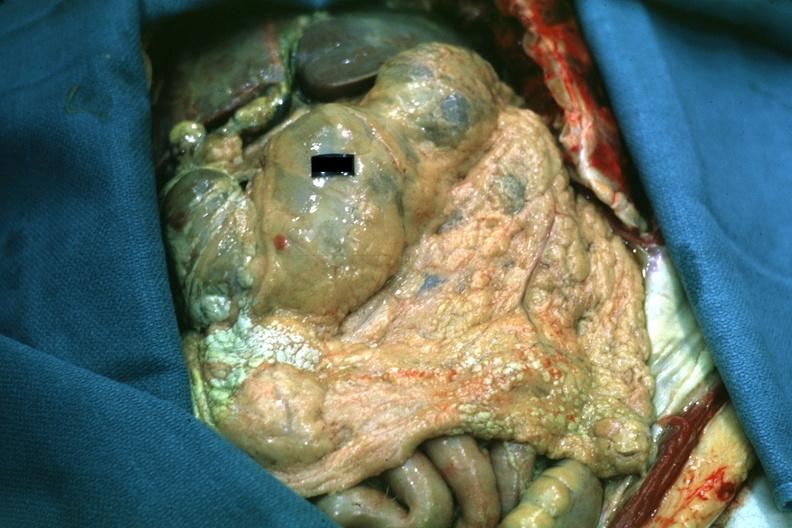s omentum present?
Answer the question using a single word or phrase. Yes 